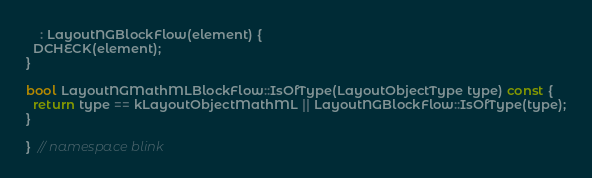<code> <loc_0><loc_0><loc_500><loc_500><_C++_>    : LayoutNGBlockFlow(element) {
  DCHECK(element);
}

bool LayoutNGMathMLBlockFlow::IsOfType(LayoutObjectType type) const {
  return type == kLayoutObjectMathML || LayoutNGBlockFlow::IsOfType(type);
}

}  // namespace blink
</code> 